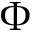<formula> <loc_0><loc_0><loc_500><loc_500>\Phi</formula> 